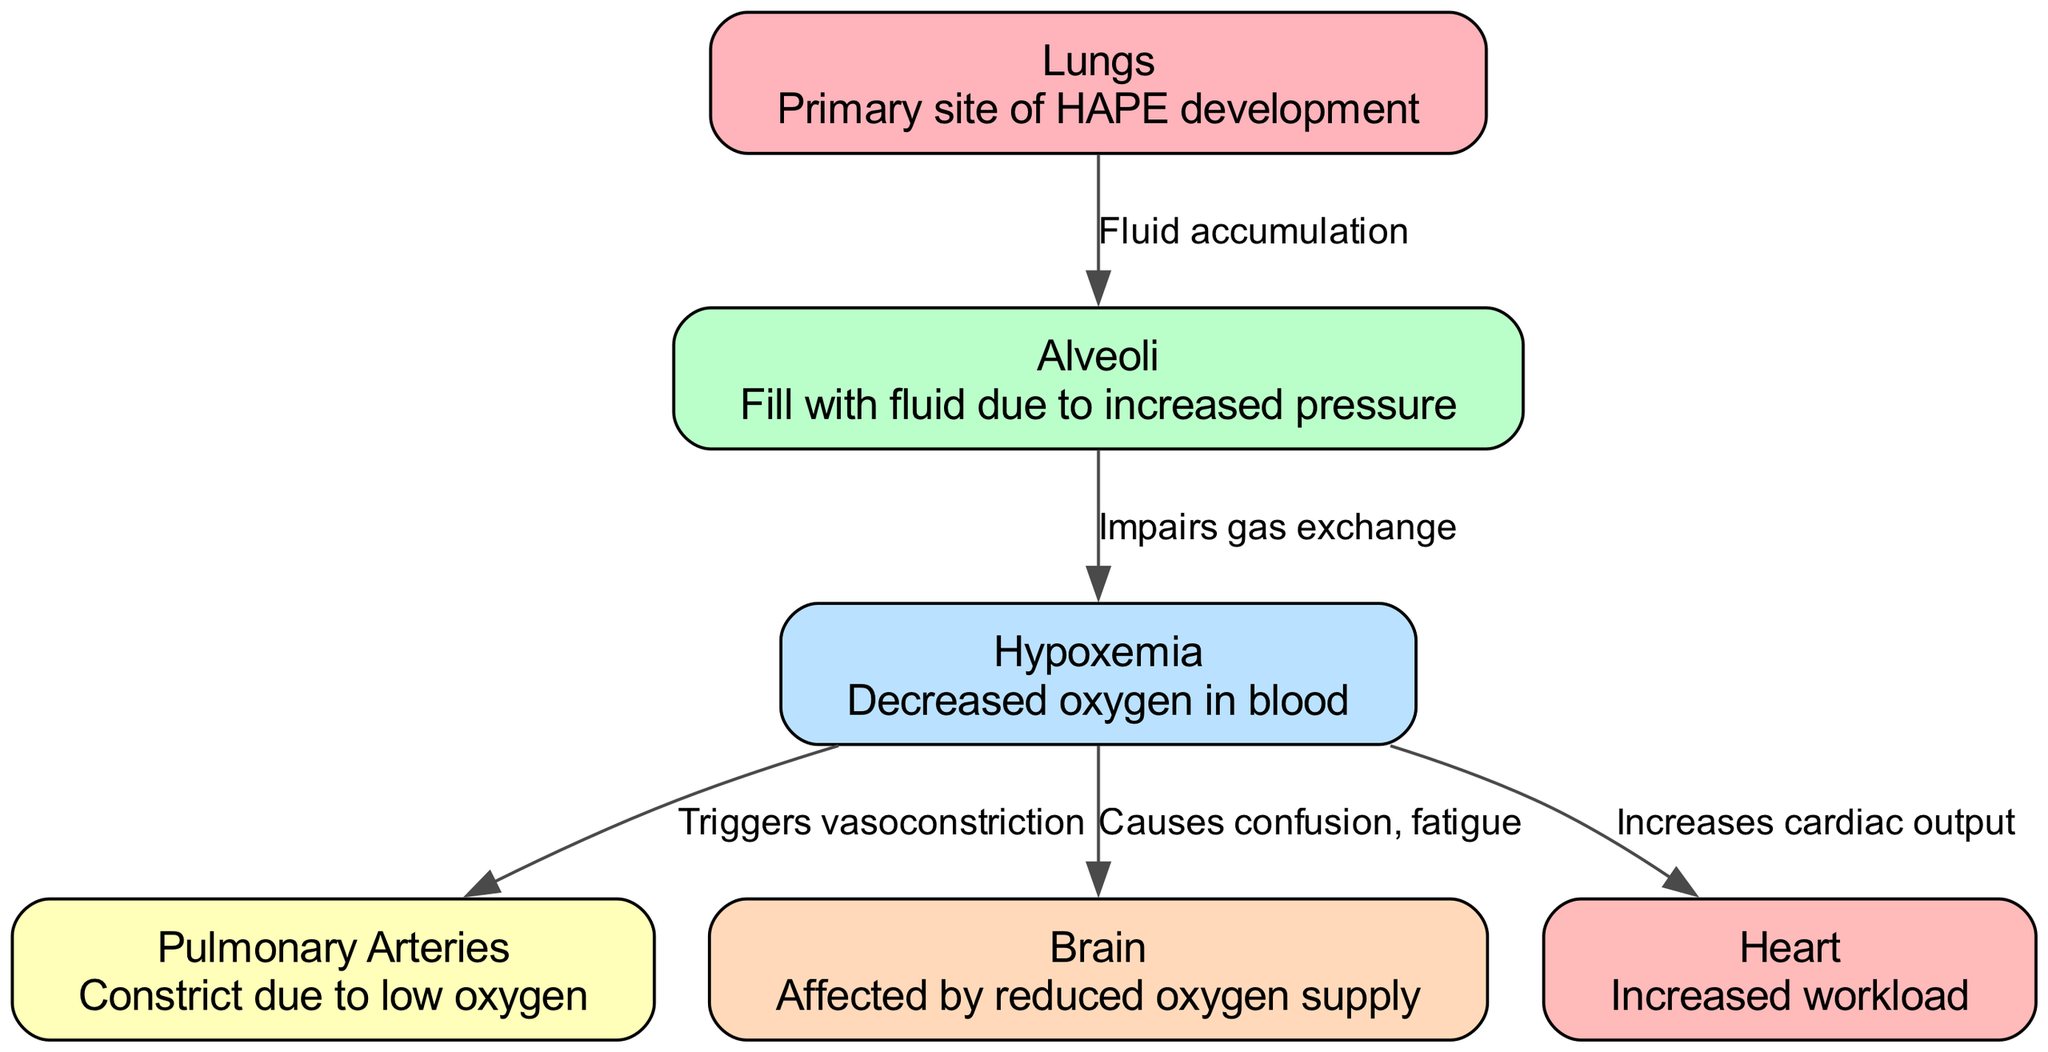What is the primary site of HAPE development? The diagram indicates that the primary site of HAPE development is the "Lungs," as the node labeled "Lungs" specifically mentions this in its description.
Answer: Lungs How does fluid accumulation affect the alveoli? The edge connecting "Lungs" to "Alveoli" is labeled "Fluid accumulation", indicating that fluid accumulation occurs as a result of HAPE and directly impacts the alveoli.
Answer: Fluid accumulation What effect does hypoxemia have on the pulmonary arteries? The edge connecting "Hypoxemia" to "Pulmonary Arteries" is labeled "Triggers vasoconstriction", which shows that hypoxemia causes pulmonary arteries to constrict.
Answer: Triggers vasoconstriction Which organ is affected by reduced oxygen supply? The "Brain" node in the diagram is described as being affected by reduced oxygen supply, indicating that hypoxemia can impact the brain.
Answer: Brain How many nodes are present in the diagram? Counting the nodes listed, there are six distinct nodes: "Lungs," "Alveoli," "Hypoxemia," "Pulmonary Arteries," "Brain," and "Heart." Therefore, the total number of nodes is six.
Answer: 6 What is the consequence of hypoxemia on heart functionality? The edge from "Hypoxemia" to "Heart" is labeled "Increases cardiac output," indicating that as hypoxemia worsens, the heart's workload increases to maintain adequate blood flow.
Answer: Increases cardiac output How is gas exchange impaired? The connection between "Alveoli" and "Hypoxemia" specifies that the accumulation of fluid in the alveoli, which is caused by HAPE, impairs gas exchange.
Answer: Impairs gas exchange What symptoms arise in the brain due to hypoxemia? The connection from "Hypoxemia" to "Brain" notes that it "Causes confusion, fatigue," signifying the neurological effects of decreased oxygen in the blood.
Answer: Causes confusion, fatigue What relationship exists between hypoxemia and the heart? The edge labeled "Increases cardiac output" indicates a direct relationship where hypoxemia requires the heart to work harder to compensate for low oxygen levels.
Answer: Increases cardiac output What process leads to fluid accumulating in the alveoli? The edge labeled "Fluid accumulation" shows the direct relationship between the "Lungs" and "Alveoli," indicating that fluid accumulates due to HAPE.
Answer: Fluid accumulation 